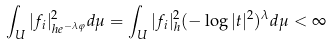<formula> <loc_0><loc_0><loc_500><loc_500>\int _ { U } | f _ { i } | _ { h e ^ { - \lambda \varphi } } ^ { 2 } d \mu = \int _ { U } | f _ { i } | ^ { 2 } _ { h } ( - \log | t | ^ { 2 } ) ^ { \lambda } d \mu < \infty</formula> 